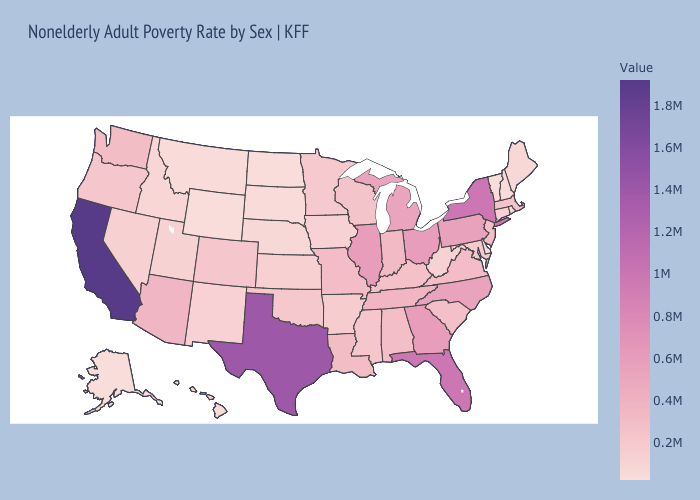Does Michigan have a higher value than Texas?
Answer briefly. No. Does Montana have the lowest value in the West?
Quick response, please. No. Among the states that border Kansas , which have the highest value?
Short answer required. Missouri. Does the map have missing data?
Quick response, please. No. Does Louisiana have the highest value in the South?
Concise answer only. No. Which states have the highest value in the USA?
Concise answer only. California. 